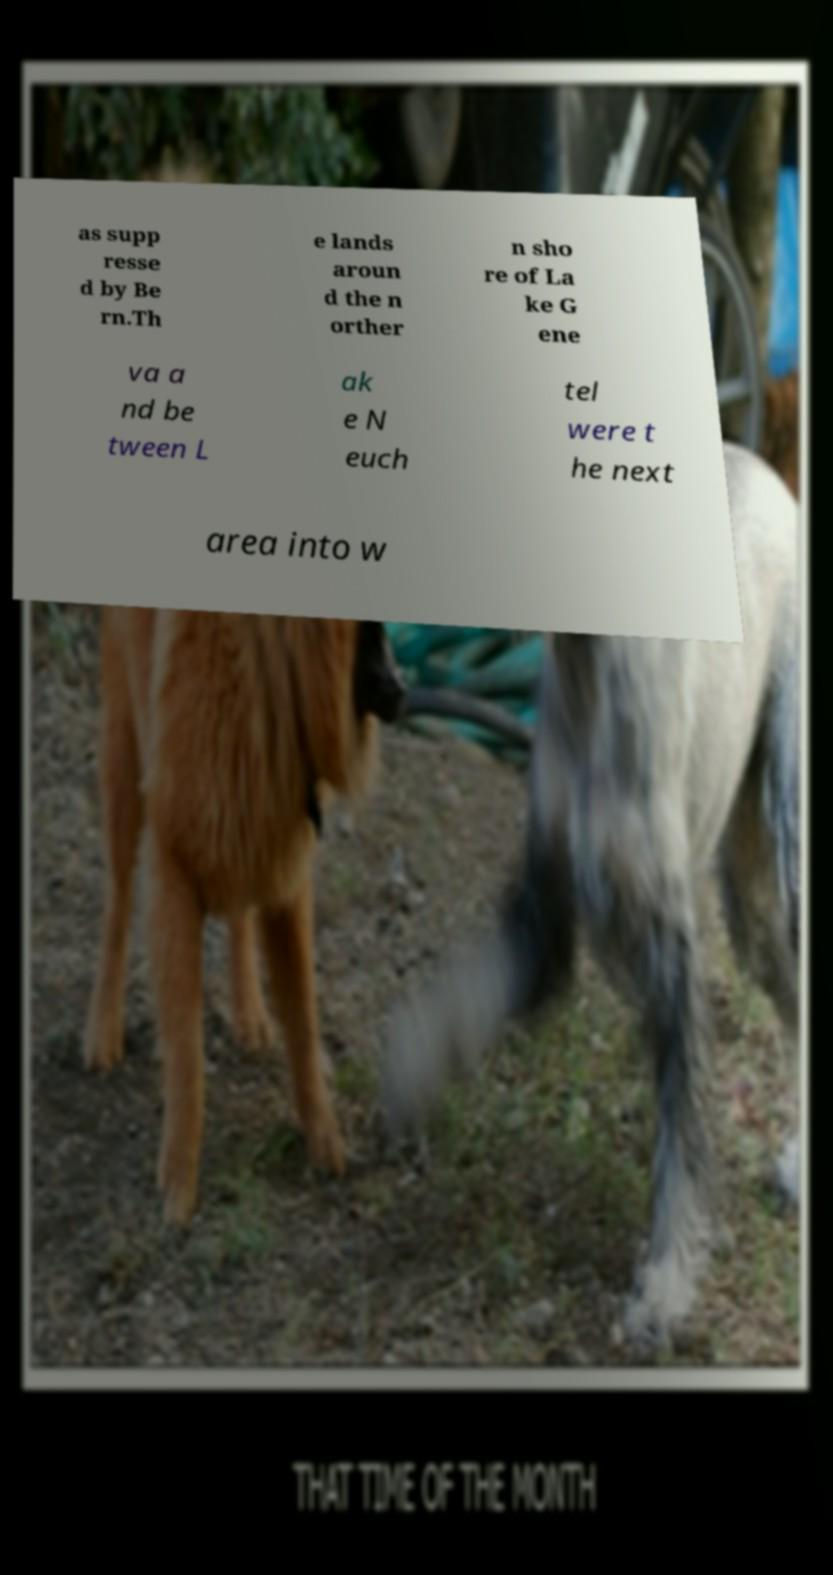For documentation purposes, I need the text within this image transcribed. Could you provide that? as supp resse d by Be rn.Th e lands aroun d the n orther n sho re of La ke G ene va a nd be tween L ak e N euch tel were t he next area into w 